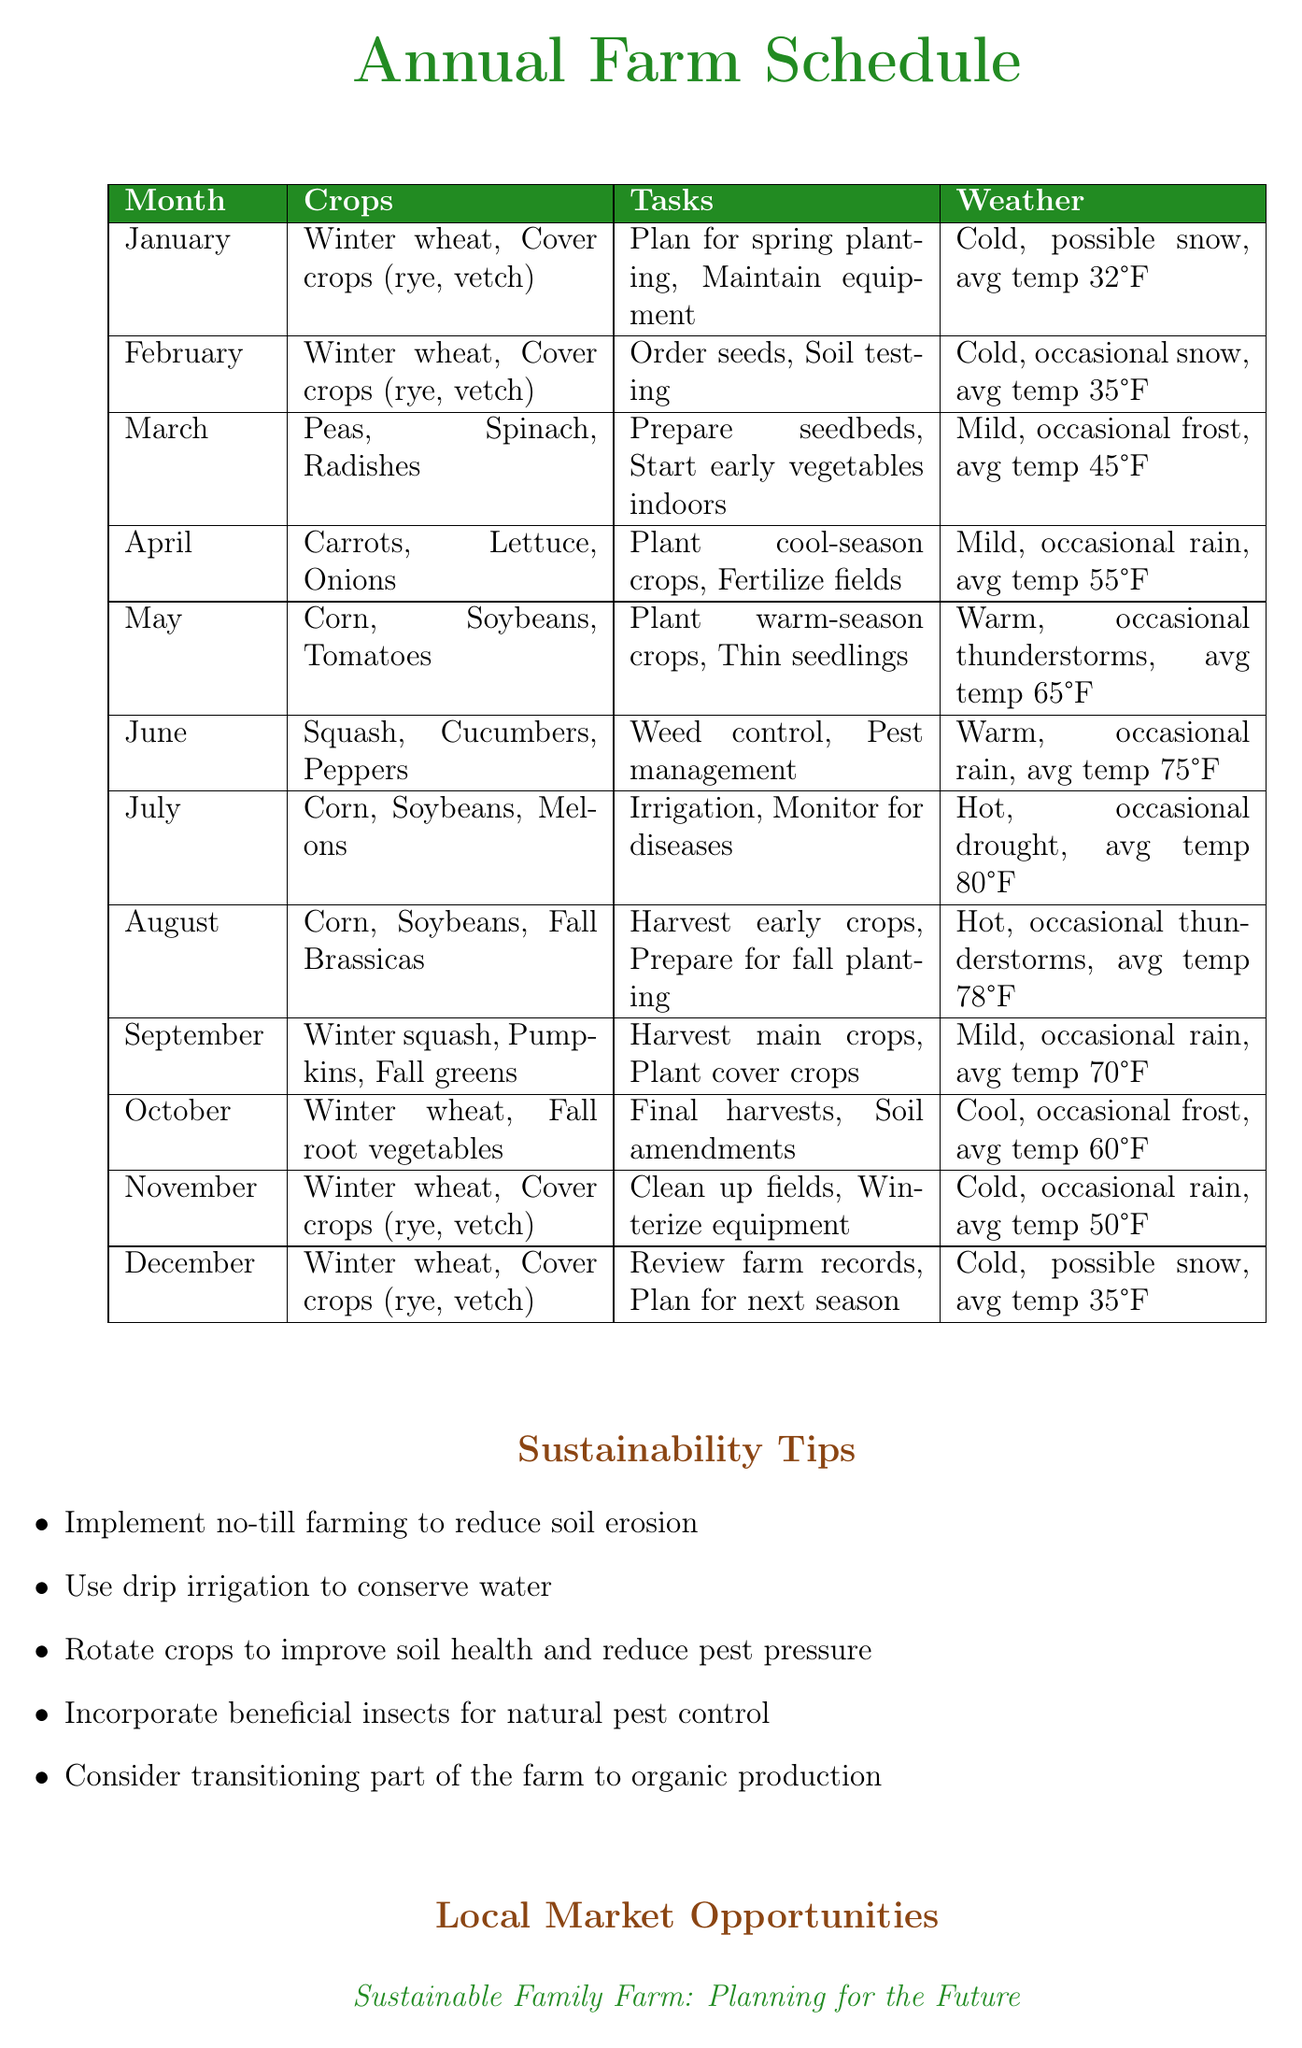What crops are planted in April? The crops listed for April include carrots, lettuce, and onions.
Answer: Carrots, Lettuce, Onions What is the average temperature in July? The document states that the average temperature in July is 80°F.
Answer: 80°F Which month is dedicated to soil testing? February is the month where soil testing is mentioned as a task.
Answer: February How many sustainability tips are provided? There are five sustainability tips listed in the document.
Answer: 5 What is a task to be completed in October? One of the tasks for October is to perform final harvests.
Answer: Final harvests What is the benefit of the Environmental Quality Incentives Program? The benefit of this program is financial assistance for implementing conservation practices.
Answer: Financial assistance for implementing conservation practices Which crops should be prepared for planting in March? The document mentions peas, spinach, and radishes for March planting.
Answer: Peas, Spinach, Radishes What average temperature is expected in September? According to the document, the average temperature in September is 70°F.
Answer: 70°F 